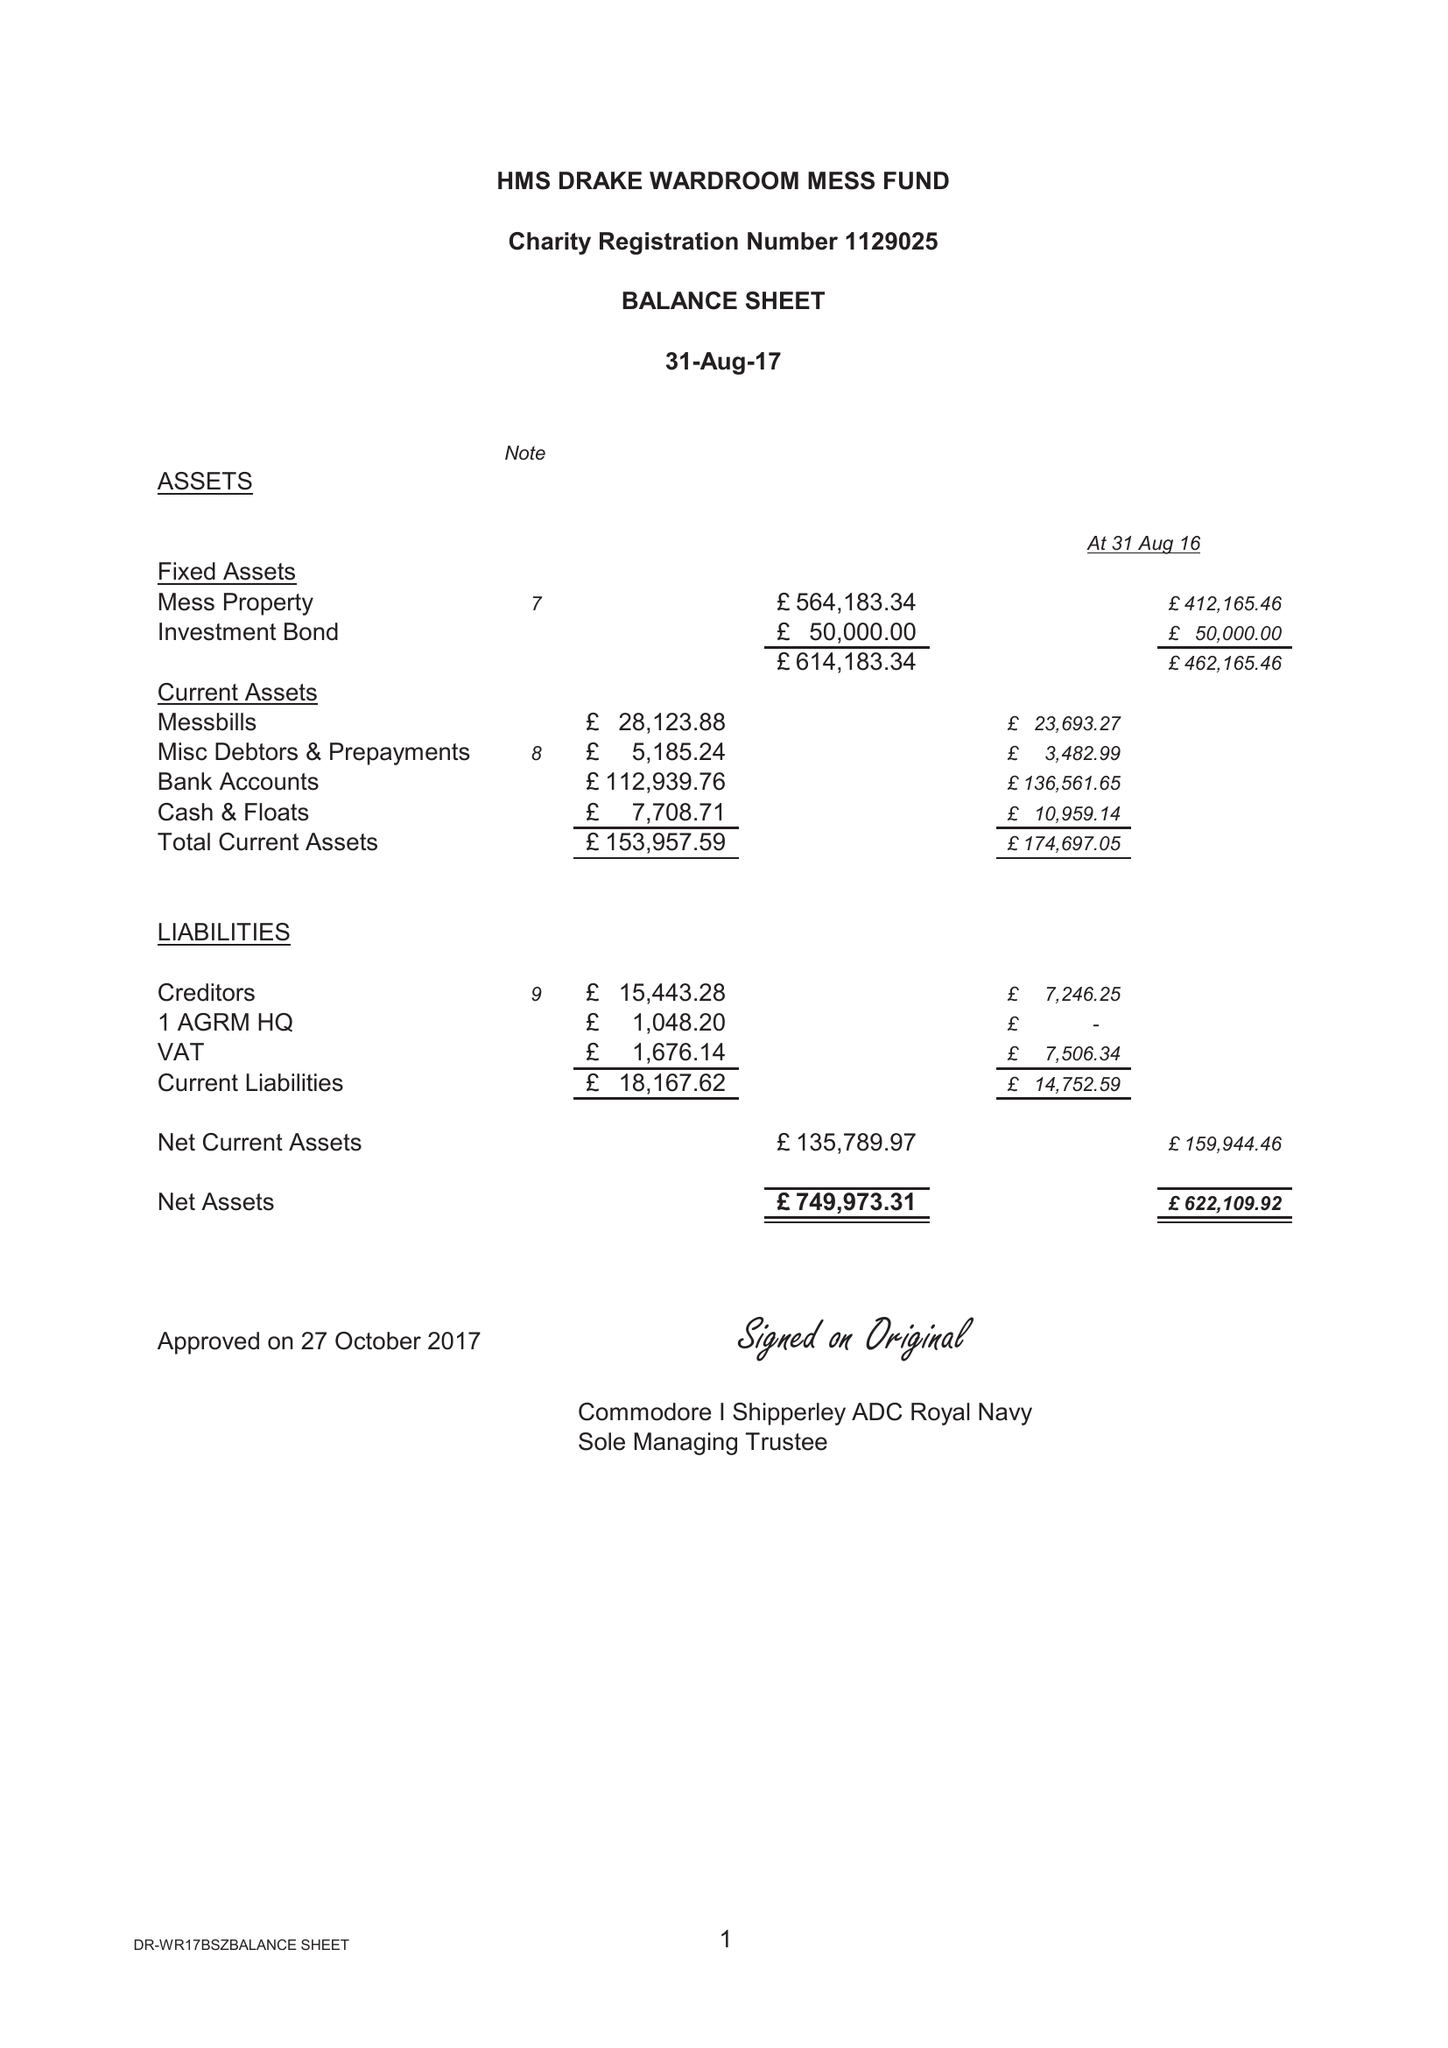What is the value for the charity_name?
Answer the question using a single word or phrase. The Wardroom Mess, Hms Drake 